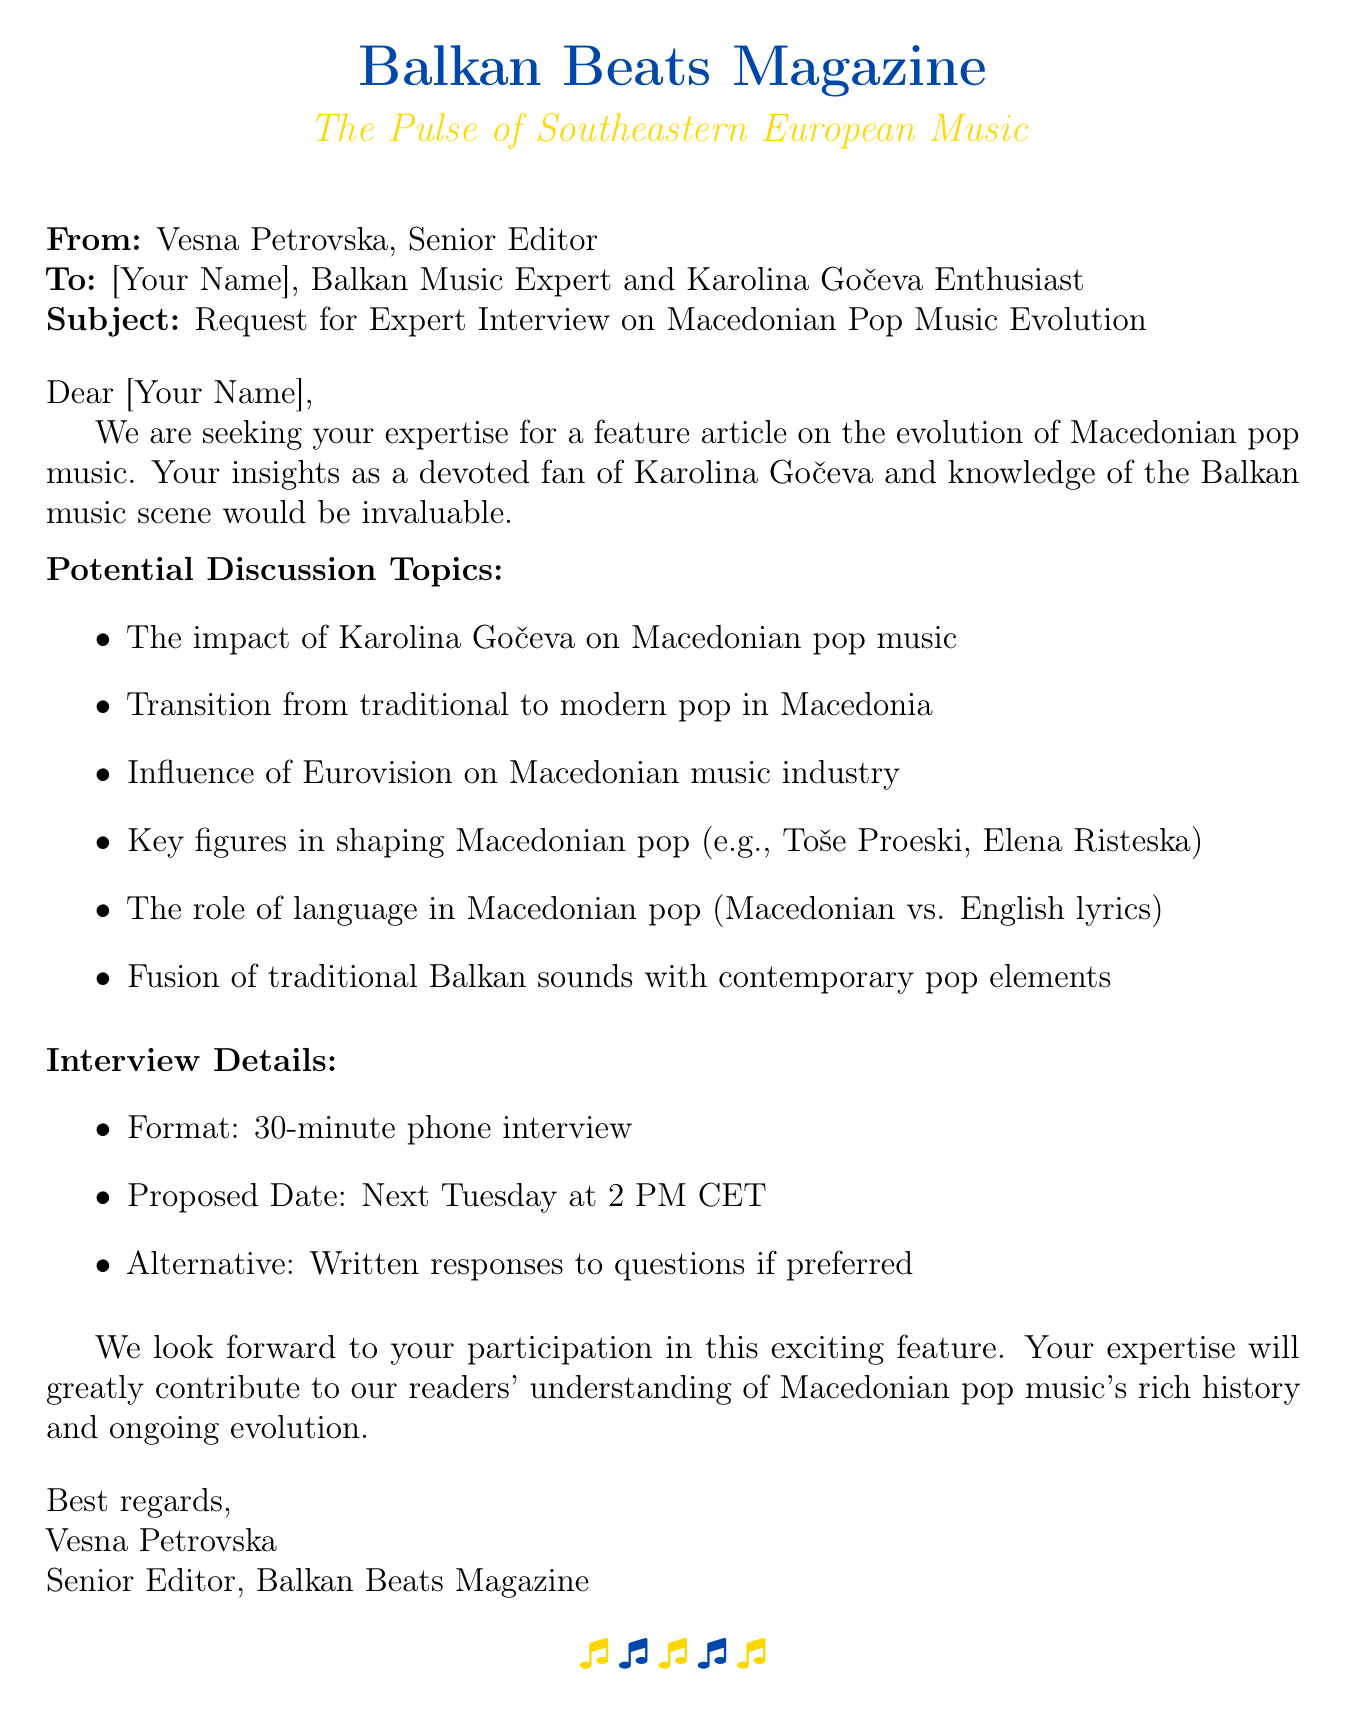What is the name of the magazine? The name of the magazine is stated at the top of the document.
Answer: Balkan Beats Magazine Who is the senior editor? The document identifies the sender of the fax as the senior editor.
Answer: Vesna Petrovska What is the subject of the fax? The subject is clearly indicated in the fax header for the recipient.
Answer: Request for Expert Interview on Macedonian Pop Music Evolution What are the proposed interview details? Details regarding the interview format and proposed time are provided in the document.
Answer: 30-minute phone interview What is one potential discussion topic listed? Discussion topics are listed in a bullet format; one example can be cited directly.
Answer: The impact of Karolina Gočeva on Macedonian pop music When is the proposed interview date? The proposed date is explicitly mentioned in the interview details section.
Answer: Next Tuesday at 2 PM CET What is the alternative to a phone interview? The fax provides an alternative format for the interview if preferred.
Answer: Written responses to questions What element of music does the document mention besides pop? The document includes specific terms related to music, indicating different styles.
Answer: Traditional Balkan sounds 